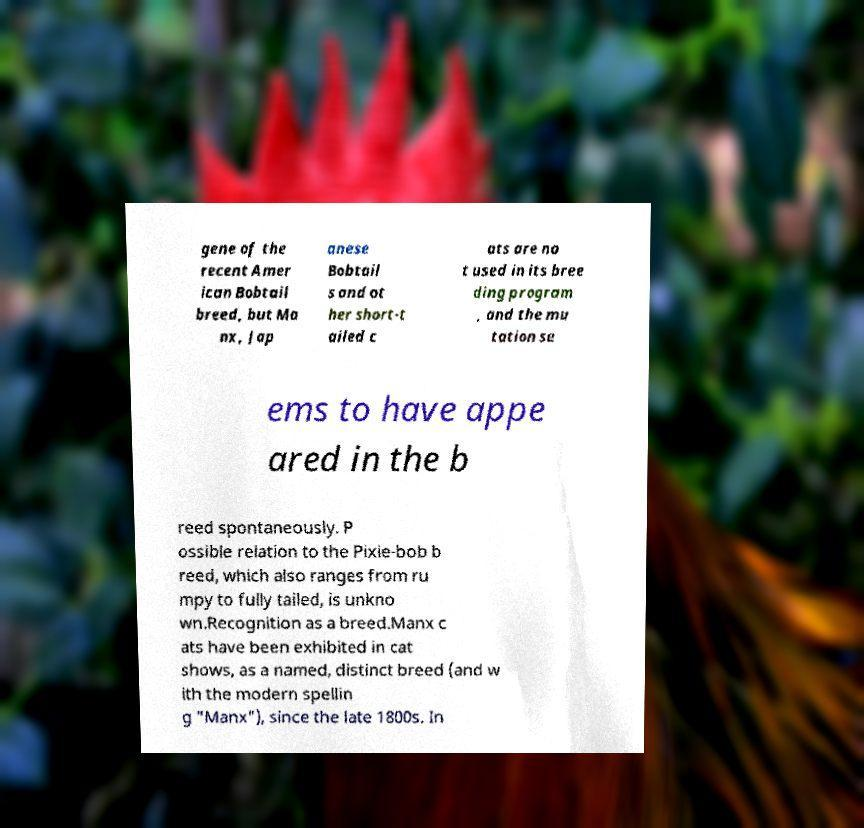Could you assist in decoding the text presented in this image and type it out clearly? gene of the recent Amer ican Bobtail breed, but Ma nx, Jap anese Bobtail s and ot her short-t ailed c ats are no t used in its bree ding program , and the mu tation se ems to have appe ared in the b reed spontaneously. P ossible relation to the Pixie-bob b reed, which also ranges from ru mpy to fully tailed, is unkno wn.Recognition as a breed.Manx c ats have been exhibited in cat shows, as a named, distinct breed (and w ith the modern spellin g "Manx"), since the late 1800s. In 